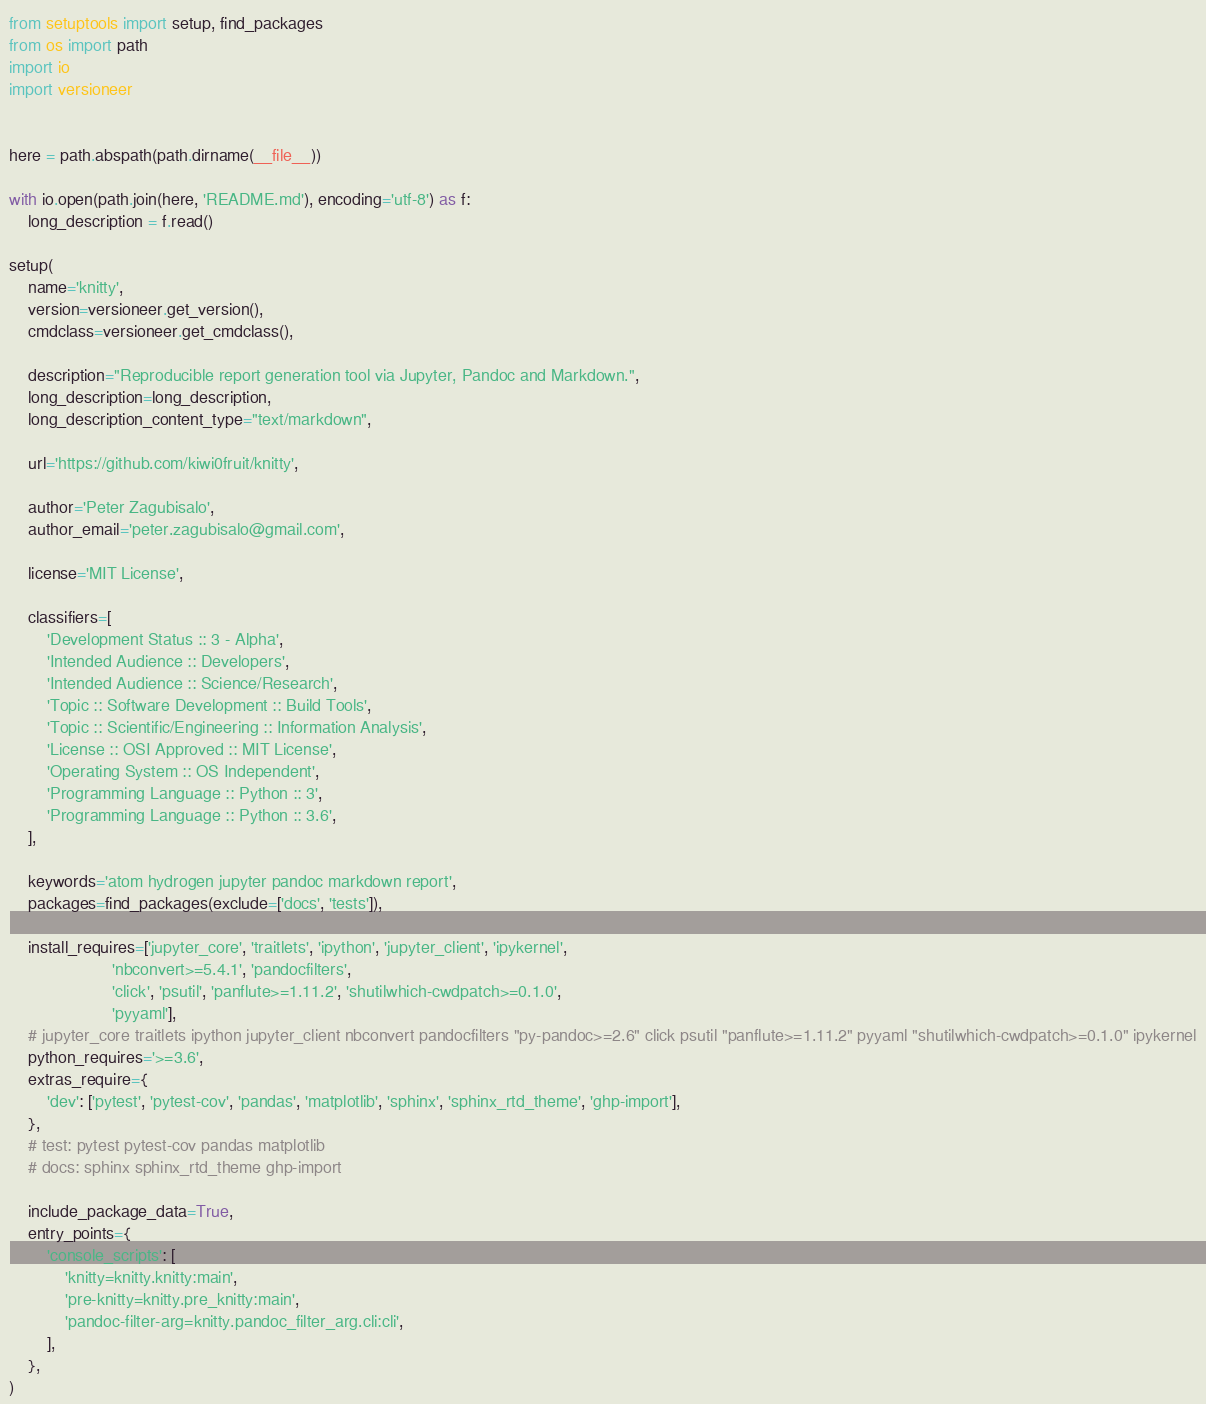Convert code to text. <code><loc_0><loc_0><loc_500><loc_500><_Python_>from setuptools import setup, find_packages
from os import path
import io
import versioneer


here = path.abspath(path.dirname(__file__))

with io.open(path.join(here, 'README.md'), encoding='utf-8') as f:
    long_description = f.read()

setup(
    name='knitty',
    version=versioneer.get_version(),
    cmdclass=versioneer.get_cmdclass(),

    description="Reproducible report generation tool via Jupyter, Pandoc and Markdown.",
    long_description=long_description,
    long_description_content_type="text/markdown",

    url='https://github.com/kiwi0fruit/knitty',

    author='Peter Zagubisalo',
    author_email='peter.zagubisalo@gmail.com',

    license='MIT License',

    classifiers=[
        'Development Status :: 3 - Alpha',
        'Intended Audience :: Developers',
        'Intended Audience :: Science/Research',
        'Topic :: Software Development :: Build Tools',
        'Topic :: Scientific/Engineering :: Information Analysis',
        'License :: OSI Approved :: MIT License',
        'Operating System :: OS Independent',
        'Programming Language :: Python :: 3',
        'Programming Language :: Python :: 3.6',
    ],

    keywords='atom hydrogen jupyter pandoc markdown report',
    packages=find_packages(exclude=['docs', 'tests']),

    install_requires=['jupyter_core', 'traitlets', 'ipython', 'jupyter_client', 'ipykernel',
                      'nbconvert>=5.4.1', 'pandocfilters',
                      'click', 'psutil', 'panflute>=1.11.2', 'shutilwhich-cwdpatch>=0.1.0',
                      'pyyaml'],
    # jupyter_core traitlets ipython jupyter_client nbconvert pandocfilters "py-pandoc>=2.6" click psutil "panflute>=1.11.2" pyyaml "shutilwhich-cwdpatch>=0.1.0" ipykernel
    python_requires='>=3.6',
    extras_require={
        'dev': ['pytest', 'pytest-cov', 'pandas', 'matplotlib', 'sphinx', 'sphinx_rtd_theme', 'ghp-import'],
    },
    # test: pytest pytest-cov pandas matplotlib
    # docs: sphinx sphinx_rtd_theme ghp-import

    include_package_data=True,
    entry_points={
        'console_scripts': [
            'knitty=knitty.knitty:main',
            'pre-knitty=knitty.pre_knitty:main',
            'pandoc-filter-arg=knitty.pandoc_filter_arg.cli:cli',
        ],
    },
)
</code> 